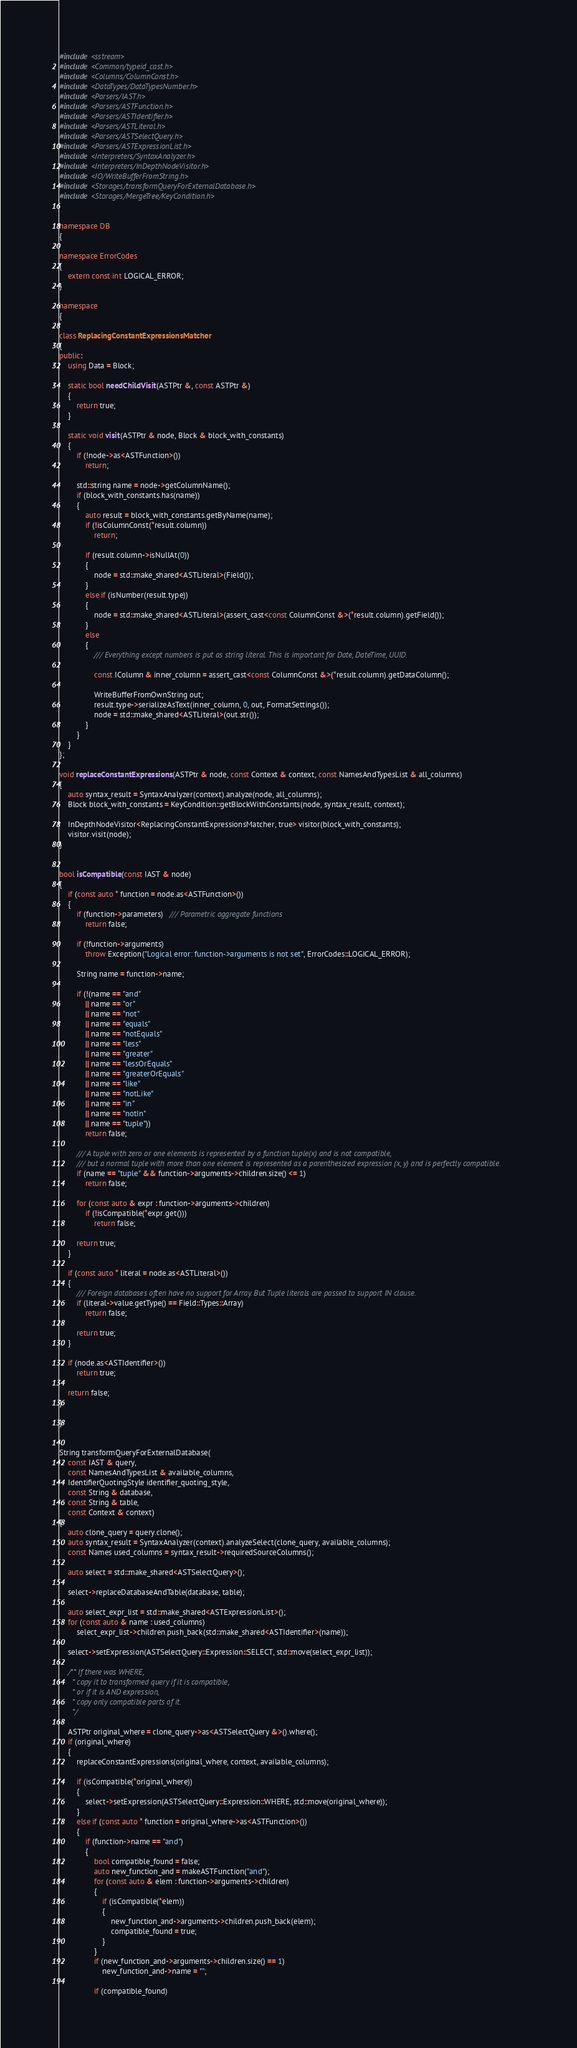Convert code to text. <code><loc_0><loc_0><loc_500><loc_500><_C++_>#include <sstream>
#include <Common/typeid_cast.h>
#include <Columns/ColumnConst.h>
#include <DataTypes/DataTypesNumber.h>
#include <Parsers/IAST.h>
#include <Parsers/ASTFunction.h>
#include <Parsers/ASTIdentifier.h>
#include <Parsers/ASTLiteral.h>
#include <Parsers/ASTSelectQuery.h>
#include <Parsers/ASTExpressionList.h>
#include <Interpreters/SyntaxAnalyzer.h>
#include <Interpreters/InDepthNodeVisitor.h>
#include <IO/WriteBufferFromString.h>
#include <Storages/transformQueryForExternalDatabase.h>
#include <Storages/MergeTree/KeyCondition.h>


namespace DB
{

namespace ErrorCodes
{
    extern const int LOGICAL_ERROR;
}

namespace
{

class ReplacingConstantExpressionsMatcher
{
public:
    using Data = Block;

    static bool needChildVisit(ASTPtr &, const ASTPtr &)
    {
        return true;
    }

    static void visit(ASTPtr & node, Block & block_with_constants)
    {
        if (!node->as<ASTFunction>())
            return;

        std::string name = node->getColumnName();
        if (block_with_constants.has(name))
        {
            auto result = block_with_constants.getByName(name);
            if (!isColumnConst(*result.column))
                return;

            if (result.column->isNullAt(0))
            {
                node = std::make_shared<ASTLiteral>(Field());
            }
            else if (isNumber(result.type))
            {
                node = std::make_shared<ASTLiteral>(assert_cast<const ColumnConst &>(*result.column).getField());
            }
            else
            {
                /// Everything except numbers is put as string literal. This is important for Date, DateTime, UUID.

                const IColumn & inner_column = assert_cast<const ColumnConst &>(*result.column).getDataColumn();

                WriteBufferFromOwnString out;
                result.type->serializeAsText(inner_column, 0, out, FormatSettings());
                node = std::make_shared<ASTLiteral>(out.str());
            }
        }
    }
};

void replaceConstantExpressions(ASTPtr & node, const Context & context, const NamesAndTypesList & all_columns)
{
    auto syntax_result = SyntaxAnalyzer(context).analyze(node, all_columns);
    Block block_with_constants = KeyCondition::getBlockWithConstants(node, syntax_result, context);

    InDepthNodeVisitor<ReplacingConstantExpressionsMatcher, true> visitor(block_with_constants);
    visitor.visit(node);
}


bool isCompatible(const IAST & node)
{
    if (const auto * function = node.as<ASTFunction>())
    {
        if (function->parameters)   /// Parametric aggregate functions
            return false;

        if (!function->arguments)
            throw Exception("Logical error: function->arguments is not set", ErrorCodes::LOGICAL_ERROR);

        String name = function->name;

        if (!(name == "and"
            || name == "or"
            || name == "not"
            || name == "equals"
            || name == "notEquals"
            || name == "less"
            || name == "greater"
            || name == "lessOrEquals"
            || name == "greaterOrEquals"
            || name == "like"
            || name == "notLike"
            || name == "in"
            || name == "notIn"
            || name == "tuple"))
            return false;

        /// A tuple with zero or one elements is represented by a function tuple(x) and is not compatible,
        /// but a normal tuple with more than one element is represented as a parenthesized expression (x, y) and is perfectly compatible.
        if (name == "tuple" && function->arguments->children.size() <= 1)
            return false;

        for (const auto & expr : function->arguments->children)
            if (!isCompatible(*expr.get()))
                return false;

        return true;
    }

    if (const auto * literal = node.as<ASTLiteral>())
    {
        /// Foreign databases often have no support for Array. But Tuple literals are passed to support IN clause.
        if (literal->value.getType() == Field::Types::Array)
            return false;

        return true;
    }

    if (node.as<ASTIdentifier>())
        return true;

    return false;
}

}


String transformQueryForExternalDatabase(
    const IAST & query,
    const NamesAndTypesList & available_columns,
    IdentifierQuotingStyle identifier_quoting_style,
    const String & database,
    const String & table,
    const Context & context)
{
    auto clone_query = query.clone();
    auto syntax_result = SyntaxAnalyzer(context).analyzeSelect(clone_query, available_columns);
    const Names used_columns = syntax_result->requiredSourceColumns();

    auto select = std::make_shared<ASTSelectQuery>();

    select->replaceDatabaseAndTable(database, table);

    auto select_expr_list = std::make_shared<ASTExpressionList>();
    for (const auto & name : used_columns)
        select_expr_list->children.push_back(std::make_shared<ASTIdentifier>(name));

    select->setExpression(ASTSelectQuery::Expression::SELECT, std::move(select_expr_list));

    /** If there was WHERE,
      * copy it to transformed query if it is compatible,
      * or if it is AND expression,
      * copy only compatible parts of it.
      */

    ASTPtr original_where = clone_query->as<ASTSelectQuery &>().where();
    if (original_where)
    {
        replaceConstantExpressions(original_where, context, available_columns);

        if (isCompatible(*original_where))
        {
            select->setExpression(ASTSelectQuery::Expression::WHERE, std::move(original_where));
        }
        else if (const auto * function = original_where->as<ASTFunction>())
        {
            if (function->name == "and")
            {
                bool compatible_found = false;
                auto new_function_and = makeASTFunction("and");
                for (const auto & elem : function->arguments->children)
                {
                    if (isCompatible(*elem))
                    {
                        new_function_and->arguments->children.push_back(elem);
                        compatible_found = true;
                    }
                }
                if (new_function_and->arguments->children.size() == 1)
                    new_function_and->name = "";

                if (compatible_found)</code> 